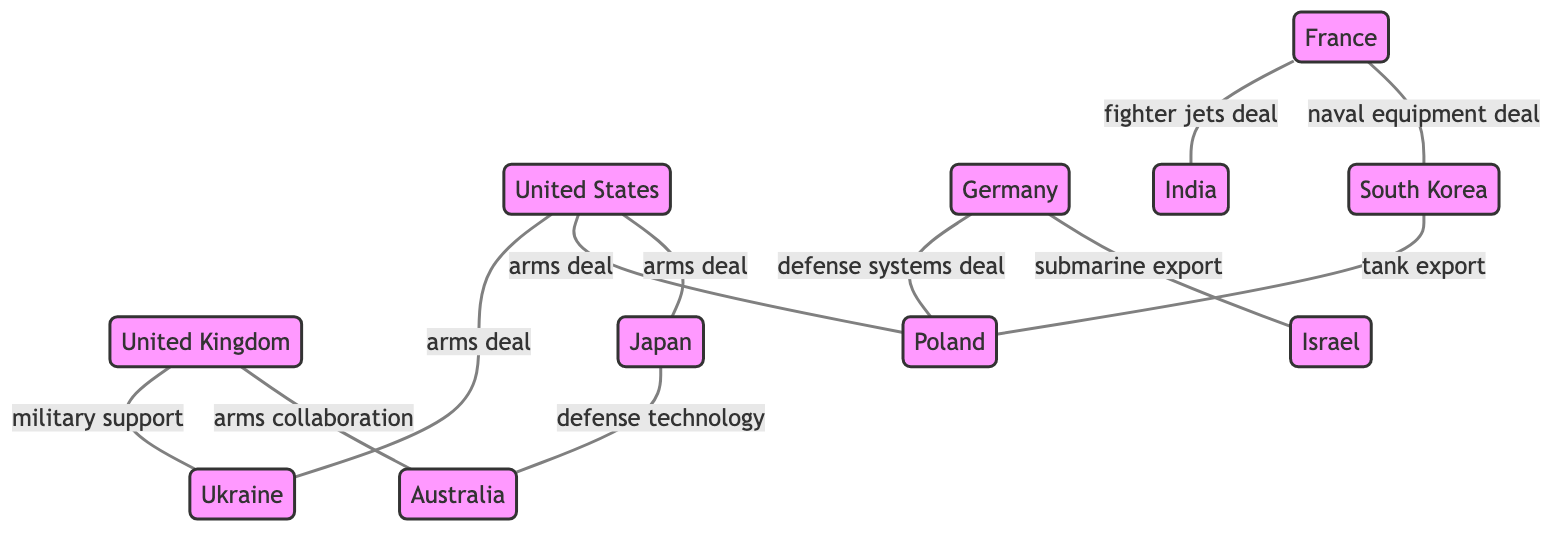What countries are connected to the United States in the graph? The United States is connected to Ukraine, Poland, and Japan as indicated by the edges labeled as arms deals.
Answer: Ukraine, Poland, Japan How many nodes are present in the diagram? The diagram lists the following nodes: United States, United Kingdom, France, Germany, Ukraine, Poland, Japan, South Korea, Australia, India, and Israel. Counting these gives a total of 11 nodes.
Answer: 11 What type of deal does Germany have with Poland? The edge between Germany and Poland is labeled as a defense systems deal, which indicates the specific nature of their relationship within the context of arms deals.
Answer: defense systems deal Which country provides military support to Ukraine? According to the diagram, the United Kingdom is associated with military support to Ukraine. This relationship is represented by the edge labeled as military support.
Answer: United Kingdom Which two countries are involved in arms collaboration according to the graph? The graph shows an edge labeled arms collaboration between the United Kingdom and Australia, indicating their cooperative relationship in this context.
Answer: United Kingdom, Australia What is the relationship between France and India? France has a direct connection to India depicted in the diagram identified as a fighter jets deal, emphasizing the specific arms deal made between these nations.
Answer: fighter jets deal Which country exports submarines to Israel? The edge from Germany to Israel is marked as a submarine export, which signifies that Germany is responsible for supplying submarines to Israel.
Answer: Germany How many edges involve Japan? Japan has three edges connecting it to Ukraine, Australia, and Poland as indicated by the relationships noted in the diagram (arms deal and defense technology). Counting these reveals that Japan is connected by three edges.
Answer: 3 What type of deal does France have with South Korea? The diagram indicates a naval equipment deal between France and South Korea, detailing the specific context of their arms trade relationship.
Answer: naval equipment deal 